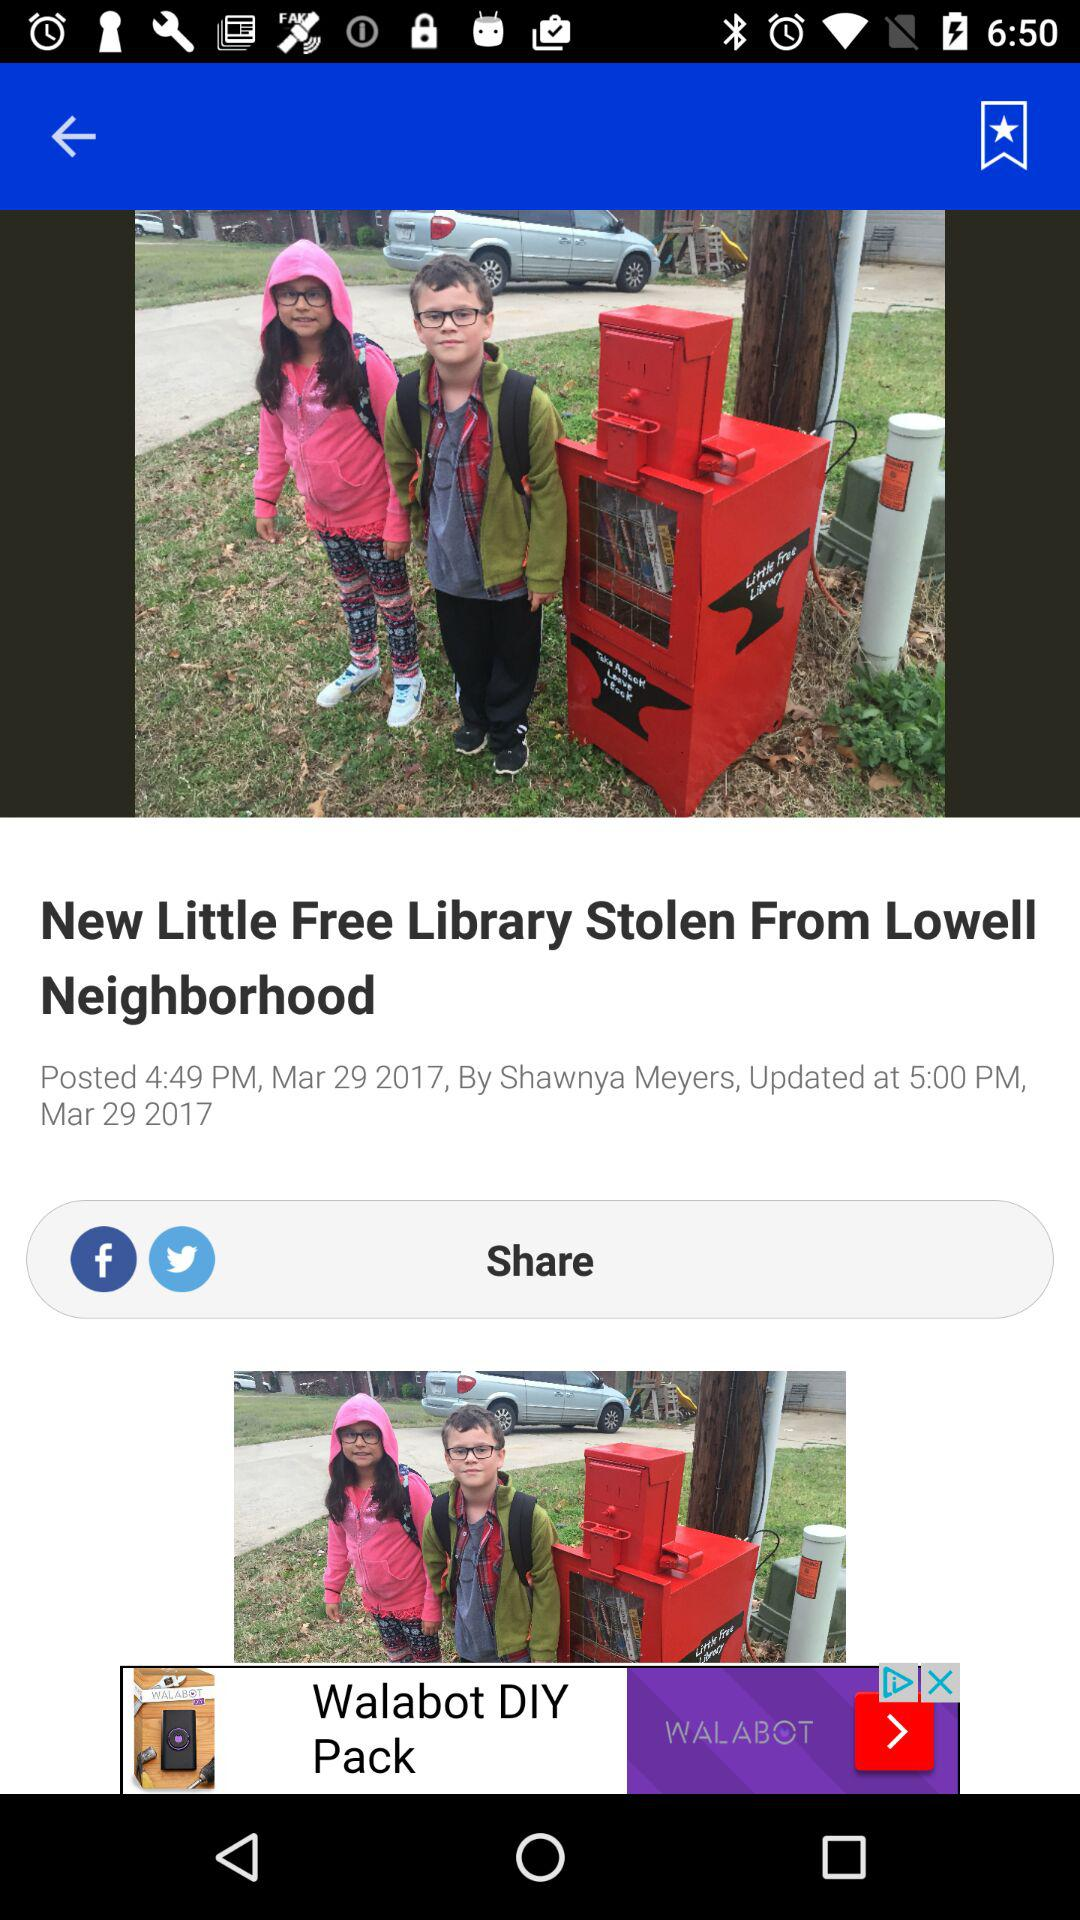What is the posted date of the article? The posted date of the article is March 29, 2017. 